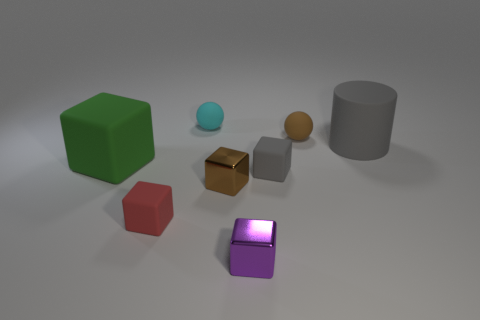Does the large matte object to the right of the brown matte object have the same color as the rubber block on the right side of the small red matte object?
Offer a terse response. Yes. Is the color of the large object behind the big green rubber thing the same as the big block?
Provide a succinct answer. No. What number of cylinders are either cyan rubber objects or red matte things?
Your answer should be compact. 0. There is a large matte object that is on the left side of the small cyan rubber ball; what is its shape?
Make the answer very short. Cube. What color is the matte block that is to the left of the small red matte cube to the left of the small brown thing that is in front of the gray cylinder?
Provide a succinct answer. Green. Do the small cyan sphere and the tiny gray cube have the same material?
Offer a very short reply. Yes. How many green objects are big matte cylinders or large things?
Your answer should be very brief. 1. What number of tiny brown metal cubes are in front of the green rubber block?
Offer a terse response. 1. Are there more objects than brown balls?
Your answer should be compact. Yes. What is the shape of the gray rubber thing in front of the big gray matte thing behind the purple cube?
Ensure brevity in your answer.  Cube. 